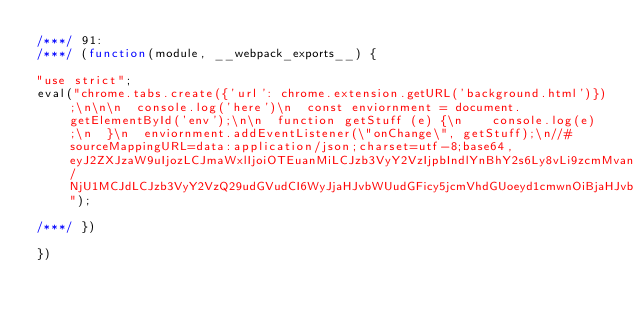Convert code to text. <code><loc_0><loc_0><loc_500><loc_500><_JavaScript_>/***/ 91:
/***/ (function(module, __webpack_exports__) {

"use strict";
eval("chrome.tabs.create({'url': chrome.extension.getURL('background.html')});\n\n\n  console.log('here')\n  const enviornment = document.getElementById('env');\n\n  function getStuff (e) {\n    console.log(e);\n  }\n  enviornment.addEventListener(\"onChange\", getStuff);\n//# sourceMappingURL=data:application/json;charset=utf-8;base64,eyJ2ZXJzaW9uIjozLCJmaWxlIjoiOTEuanMiLCJzb3VyY2VzIjpbIndlYnBhY2s6Ly8vLi9zcmMvanMvcG9wdXAuanM/NjU1MCJdLCJzb3VyY2VzQ29udGVudCI6WyJjaHJvbWUudGFicy5jcmVhdGUoeyd1cmwnOiBjaHJvbWUuZXh0ZW5zaW9uLmdldFVSTCgnYmFja2dyb3VuZC5odG1sJyl9KTtcblxuXG4gIGNvbnNvbGUubG9nKCdoZXJlJylcbiAgY29uc3QgZW52aW9ybm1lbnQgPSBkb2N1bWVudC5nZXRFbGVtZW50QnlJZCgnZW52Jyk7XG5cbiAgZnVuY3Rpb24gZ2V0U3R1ZmYgKGUpIHtcbiAgICBjb25zb2xlLmxvZyhlKTtcbiAgfVxuICBlbnZpb3JubWVudC5hZGRFdmVudExpc3RlbmVyKFwib25DaGFuZ2VcIiwgZ2V0U3R1ZmYpO1xuXG5cblxuLy8vLy8vLy8vLy8vLy8vLy8vXG4vLyBXRUJQQUNLIEZPT1RFUlxuLy8gLi9zcmMvanMvcG9wdXAuanNcbi8vIG1vZHVsZSBpZCA9IDkxXG4vLyBtb2R1bGUgY2h1bmtzID0gMCJdLCJtYXBwaW5ncyI6IkFBQUE7QUFDQTtBQUNBO0FBQ0E7QUFDQTtBQUNBO0FBQ0E7QUFDQTtBQUNBO0FBQ0E7Iiwic291cmNlUm9vdCI6IiJ9");

/***/ })

})</code> 